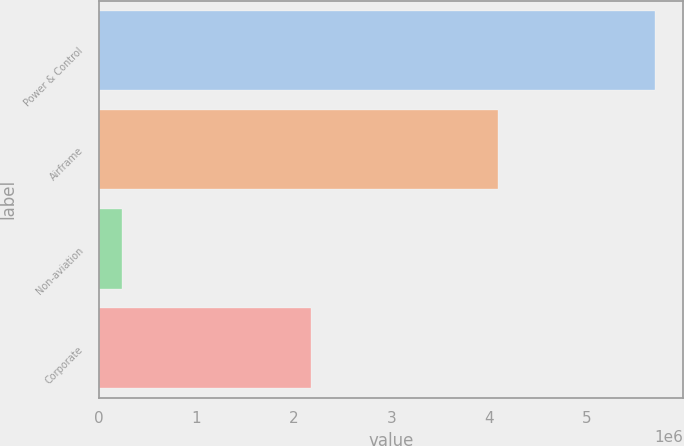<chart> <loc_0><loc_0><loc_500><loc_500><bar_chart><fcel>Power & Control<fcel>Airframe<fcel>Non-aviation<fcel>Corporate<nl><fcel>5.69852e+06<fcel>4.09101e+06<fcel>234770<fcel>2.17316e+06<nl></chart> 